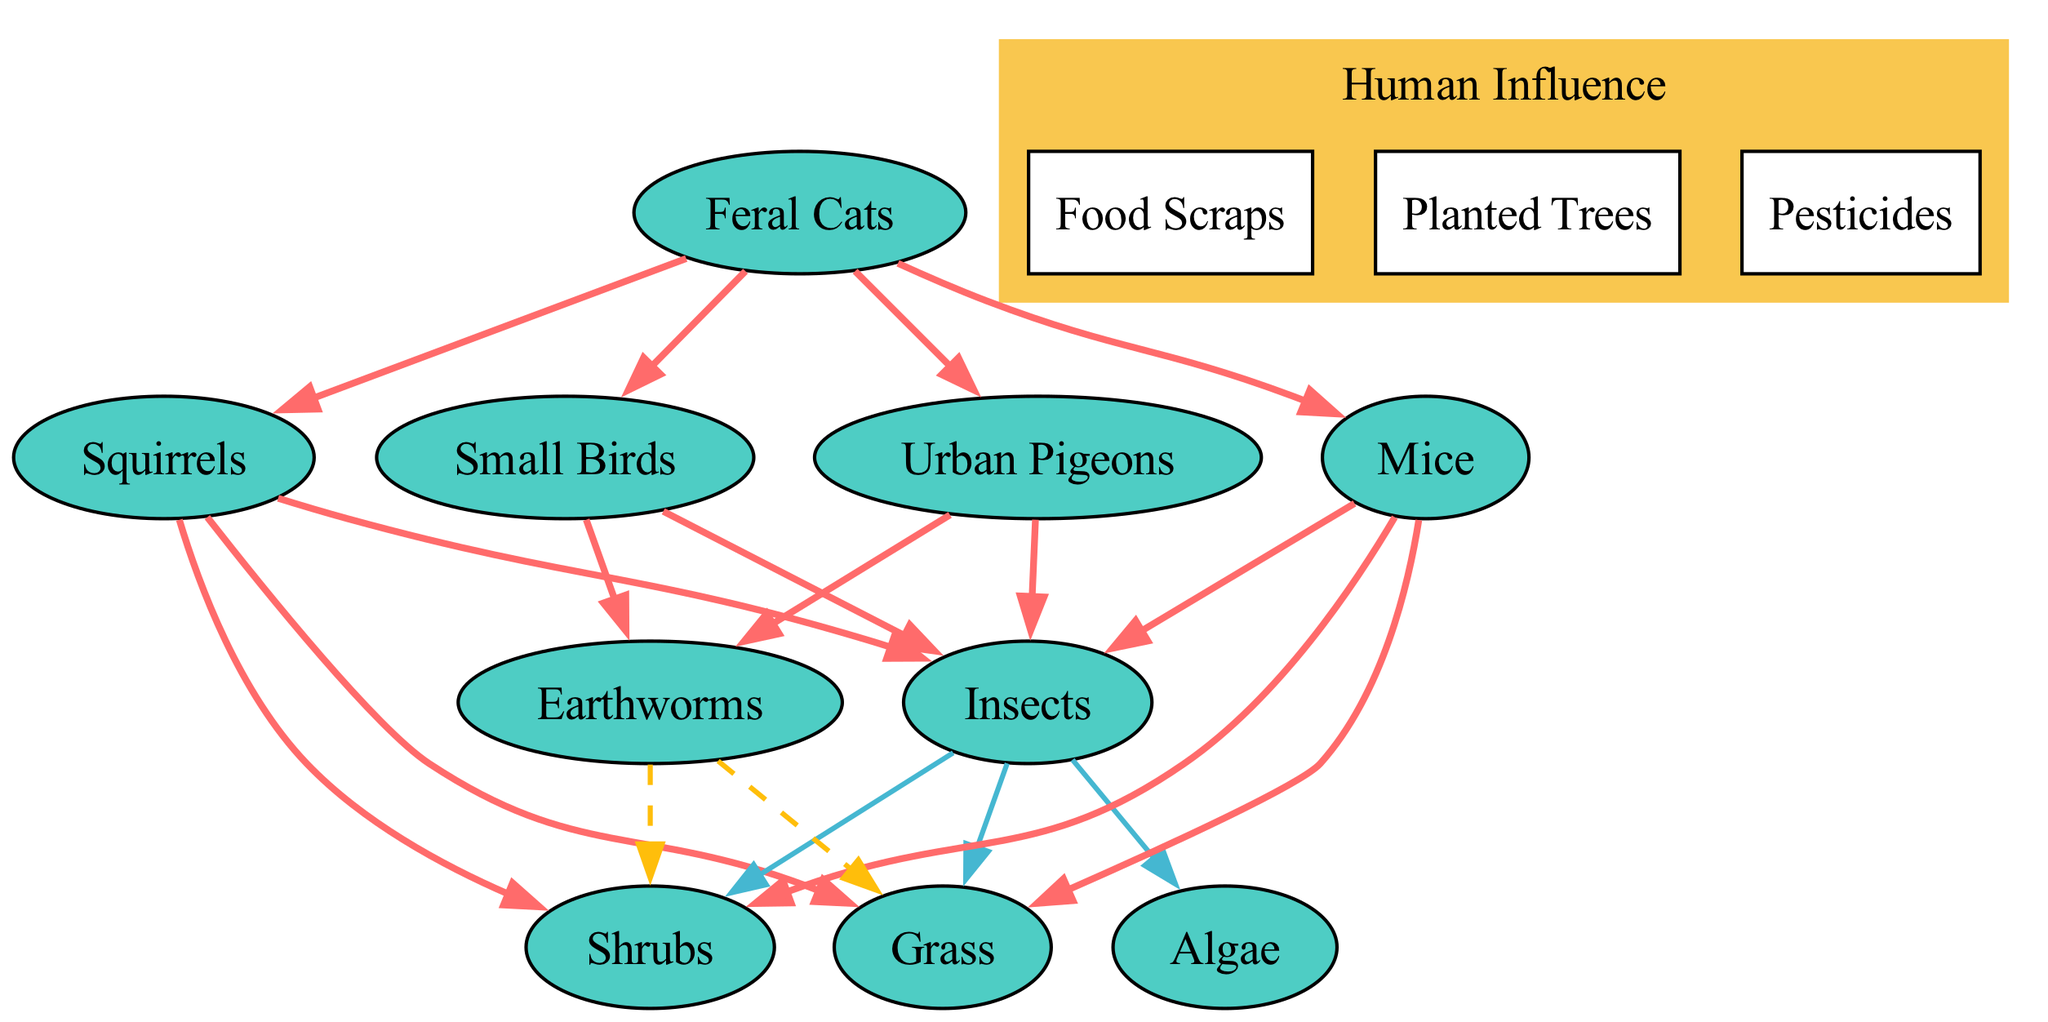What is the total number of organisms represented in the diagram? The diagram features a total of 10 organisms listed in the data, which includes Urban Pigeons, Squirrels, Feral Cats, Insects, Small Birds, Mice, Earthworms, Grass, Shrubs, and Algae.
Answer: 10 Which organism is a predator of Urban Pigeons? According to the relationships defined in the data, Feral Cats are listed as a predator of Urban Pigeons.
Answer: Feral Cats How many organisms does Squirrels prey on? The data shows that Squirrels prey on three different organisms: Insects, Grass, and Shrubs.
Answer: 3 What type of interaction does Earthworms have with Grass? Earthworms are classified as decomposers in the diagram and decompose Grass as indicated in the relationships data.
Answer: Decomposes Which organism is influenced by pesticides? The data identifies human influences in the urban park, including 'Pesticides', which can impact various organisms. However, it does not specify a particular organism directly affected, but we understand that pesticides can influence insects and other small wildlife.
Answer: Insects Which type of influence do food scraps represent? Food scraps are listed under human influence, showcasing how human activity can provide additional food sources, particularly to urban wildlife such as pigeons and squirrels.
Answer: Human Influence What color is used to represent the predatory relationships in the diagram? The color scheme specifies that the predatory relationships are represented by the color '#FF6B6B' in the diagram.
Answer: Red How many decomposers are represented in the diagram? The diagram shows there is one decomposer, which is the Earthworms, as listed in the relationships section.
Answer: 1 Which organism consumes both Grass and Shrubs? The data indicates that both Squirrels and Mice consume Grass and Shrubs.
Answer: Squirrels and Mice 